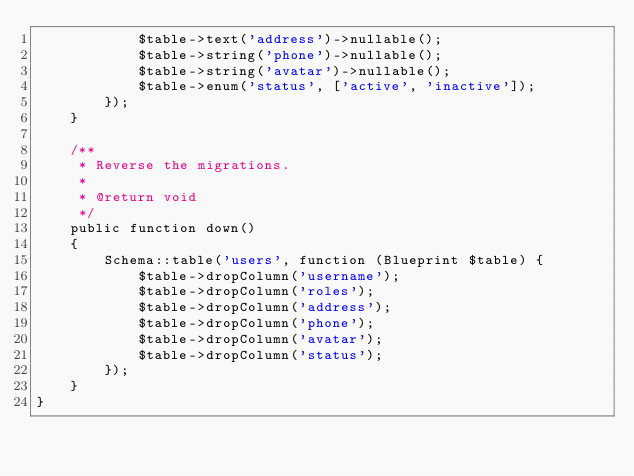Convert code to text. <code><loc_0><loc_0><loc_500><loc_500><_PHP_>            $table->text('address')->nullable();
            $table->string('phone')->nullable();
            $table->string('avatar')->nullable();
            $table->enum('status', ['active', 'inactive']);
        });
    }

    /**
     * Reverse the migrations.
     *
     * @return void
     */
    public function down()
    {
        Schema::table('users', function (Blueprint $table) {
            $table->dropColumn('username');
            $table->dropColumn('roles');
            $table->dropColumn('address');
            $table->dropColumn('phone');
            $table->dropColumn('avatar');
            $table->dropColumn('status');
        });
    }
}
</code> 